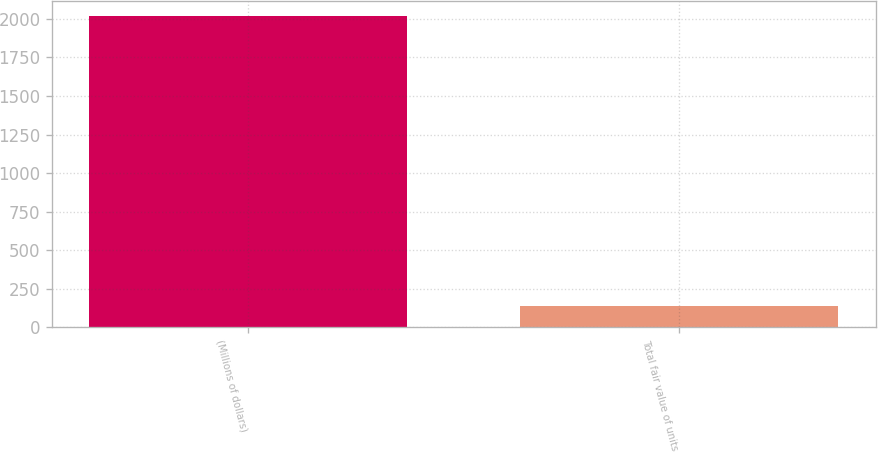<chart> <loc_0><loc_0><loc_500><loc_500><bar_chart><fcel>(Millions of dollars)<fcel>Total fair value of units<nl><fcel>2017<fcel>139<nl></chart> 